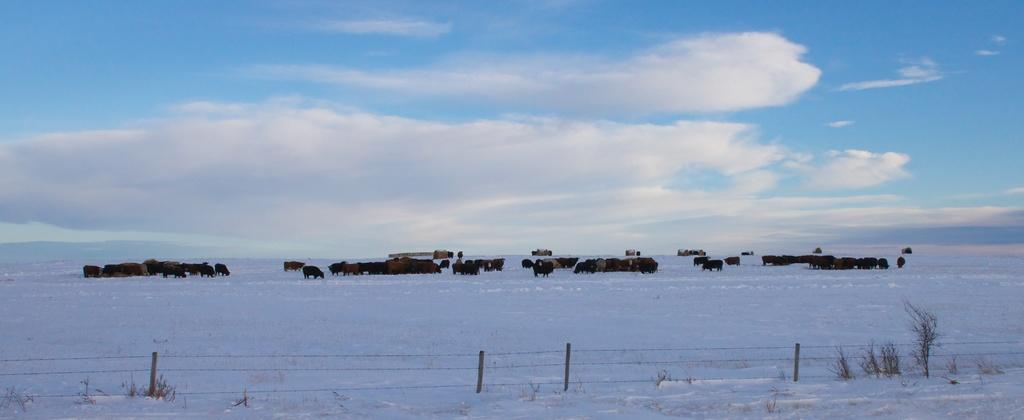What is located at the front of the image? There is fencing in the front of the image. What is visible at the bottom of the image? There is snow at the bottom of the image. What can be seen in the middle of the image? There is a group of animals in the middle of the image. What is visible at the top of the image? The sky is visible at the top of the image. What can be observed in the sky? Clouds are present in the sky. Can you tell me how many kittens are playing with the father and hen in the image? There are no kittens, father, or hen present in the image. What type of hen is shown interacting with the father and kittens in the image? There is no hen or father present in the image, and therefore no such interaction can be observed. 